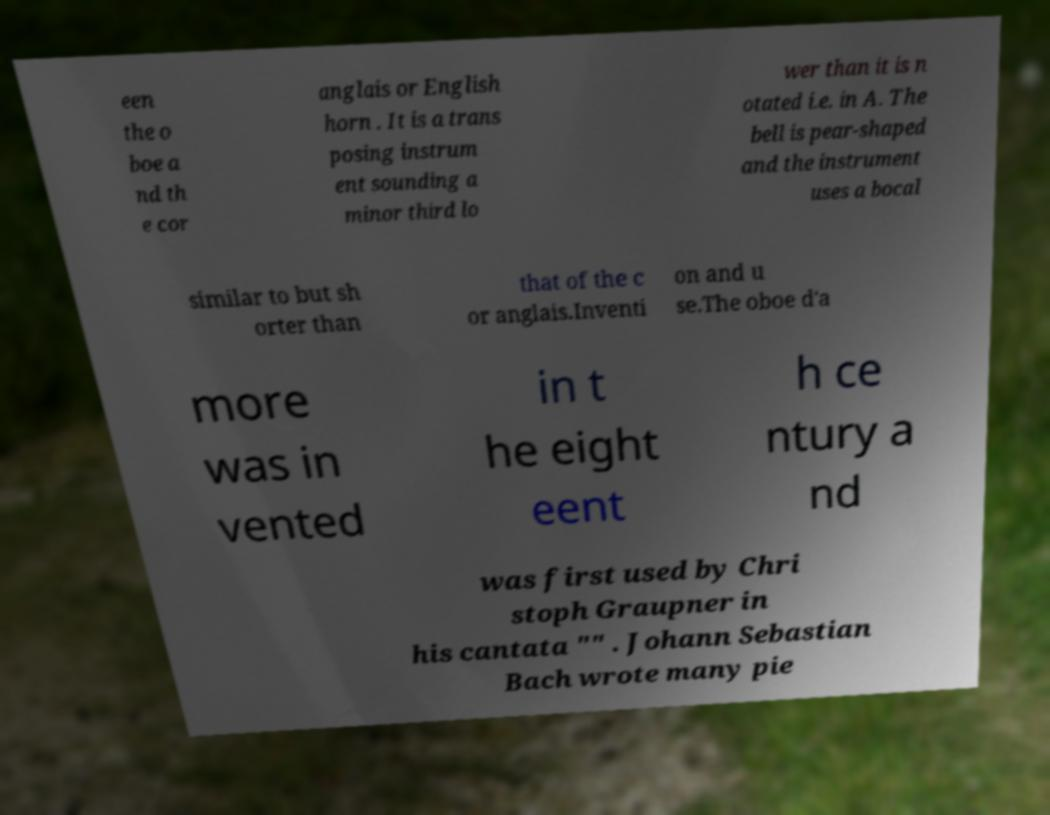What messages or text are displayed in this image? I need them in a readable, typed format. een the o boe a nd th e cor anglais or English horn . It is a trans posing instrum ent sounding a minor third lo wer than it is n otated i.e. in A. The bell is pear-shaped and the instrument uses a bocal similar to but sh orter than that of the c or anglais.Inventi on and u se.The oboe d'a more was in vented in t he eight eent h ce ntury a nd was first used by Chri stoph Graupner in his cantata "" . Johann Sebastian Bach wrote many pie 